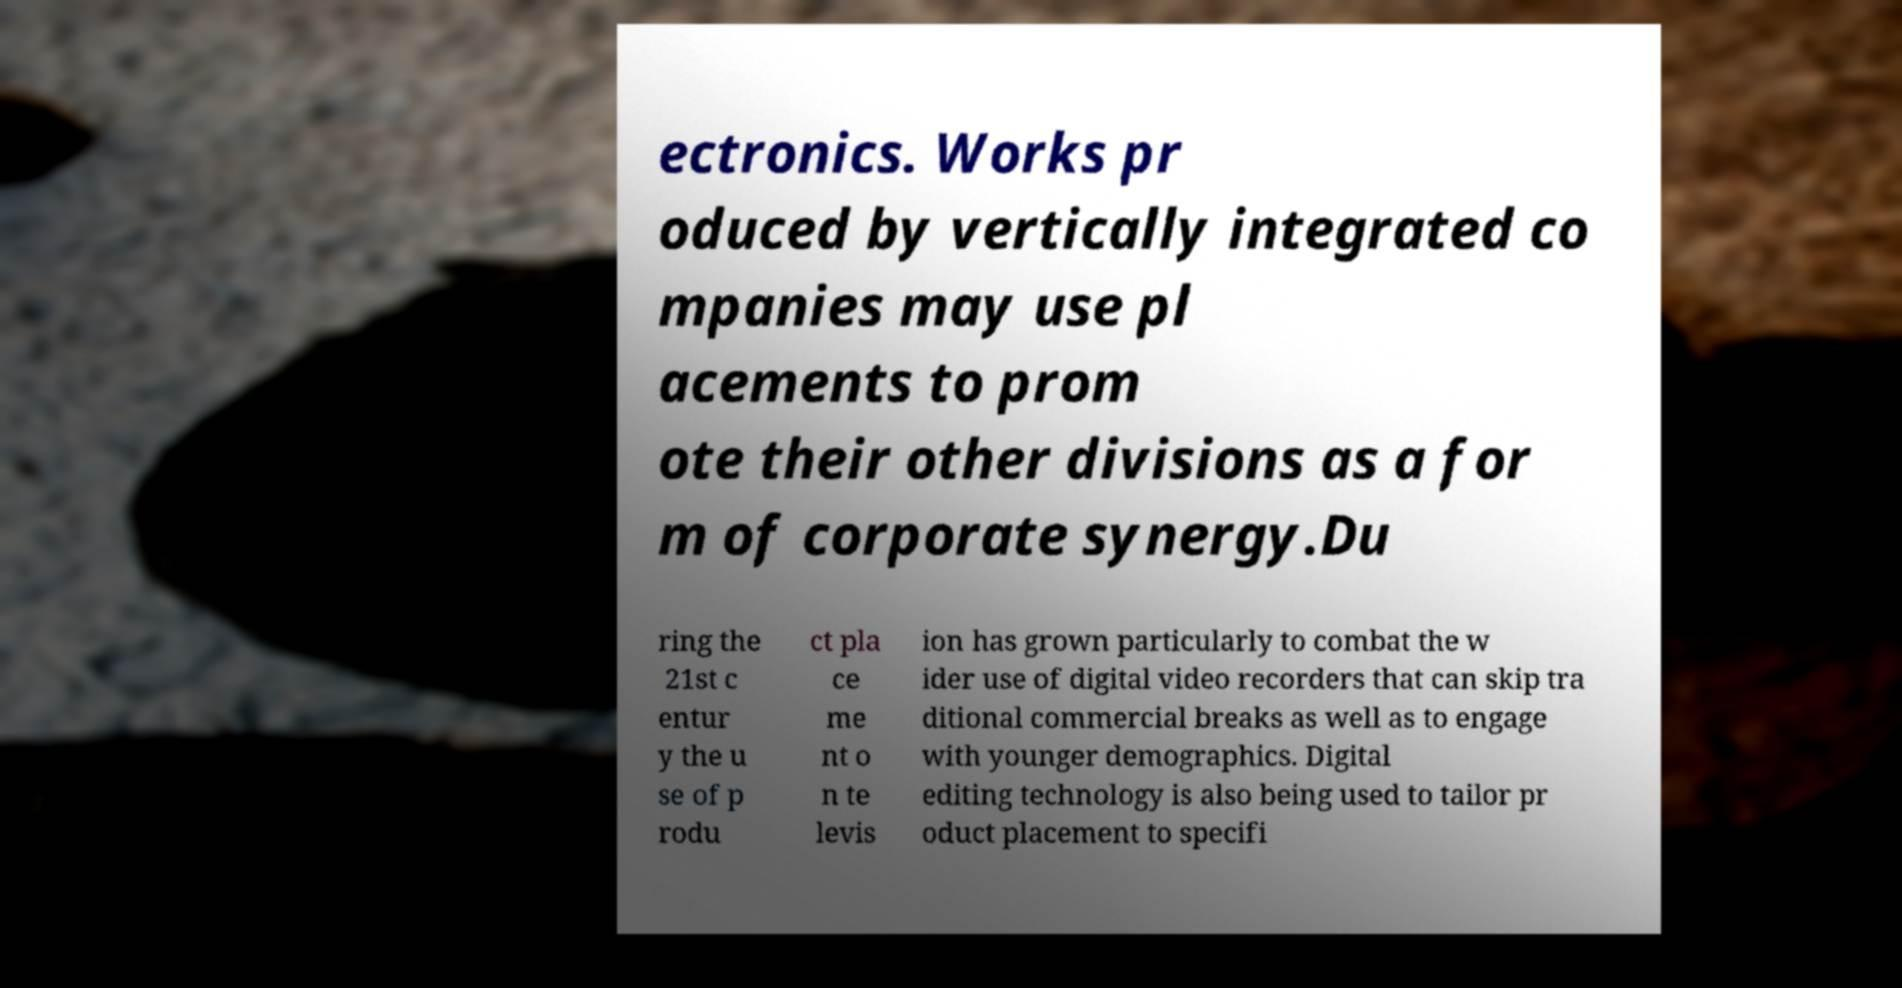Can you read and provide the text displayed in the image?This photo seems to have some interesting text. Can you extract and type it out for me? ectronics. Works pr oduced by vertically integrated co mpanies may use pl acements to prom ote their other divisions as a for m of corporate synergy.Du ring the 21st c entur y the u se of p rodu ct pla ce me nt o n te levis ion has grown particularly to combat the w ider use of digital video recorders that can skip tra ditional commercial breaks as well as to engage with younger demographics. Digital editing technology is also being used to tailor pr oduct placement to specifi 